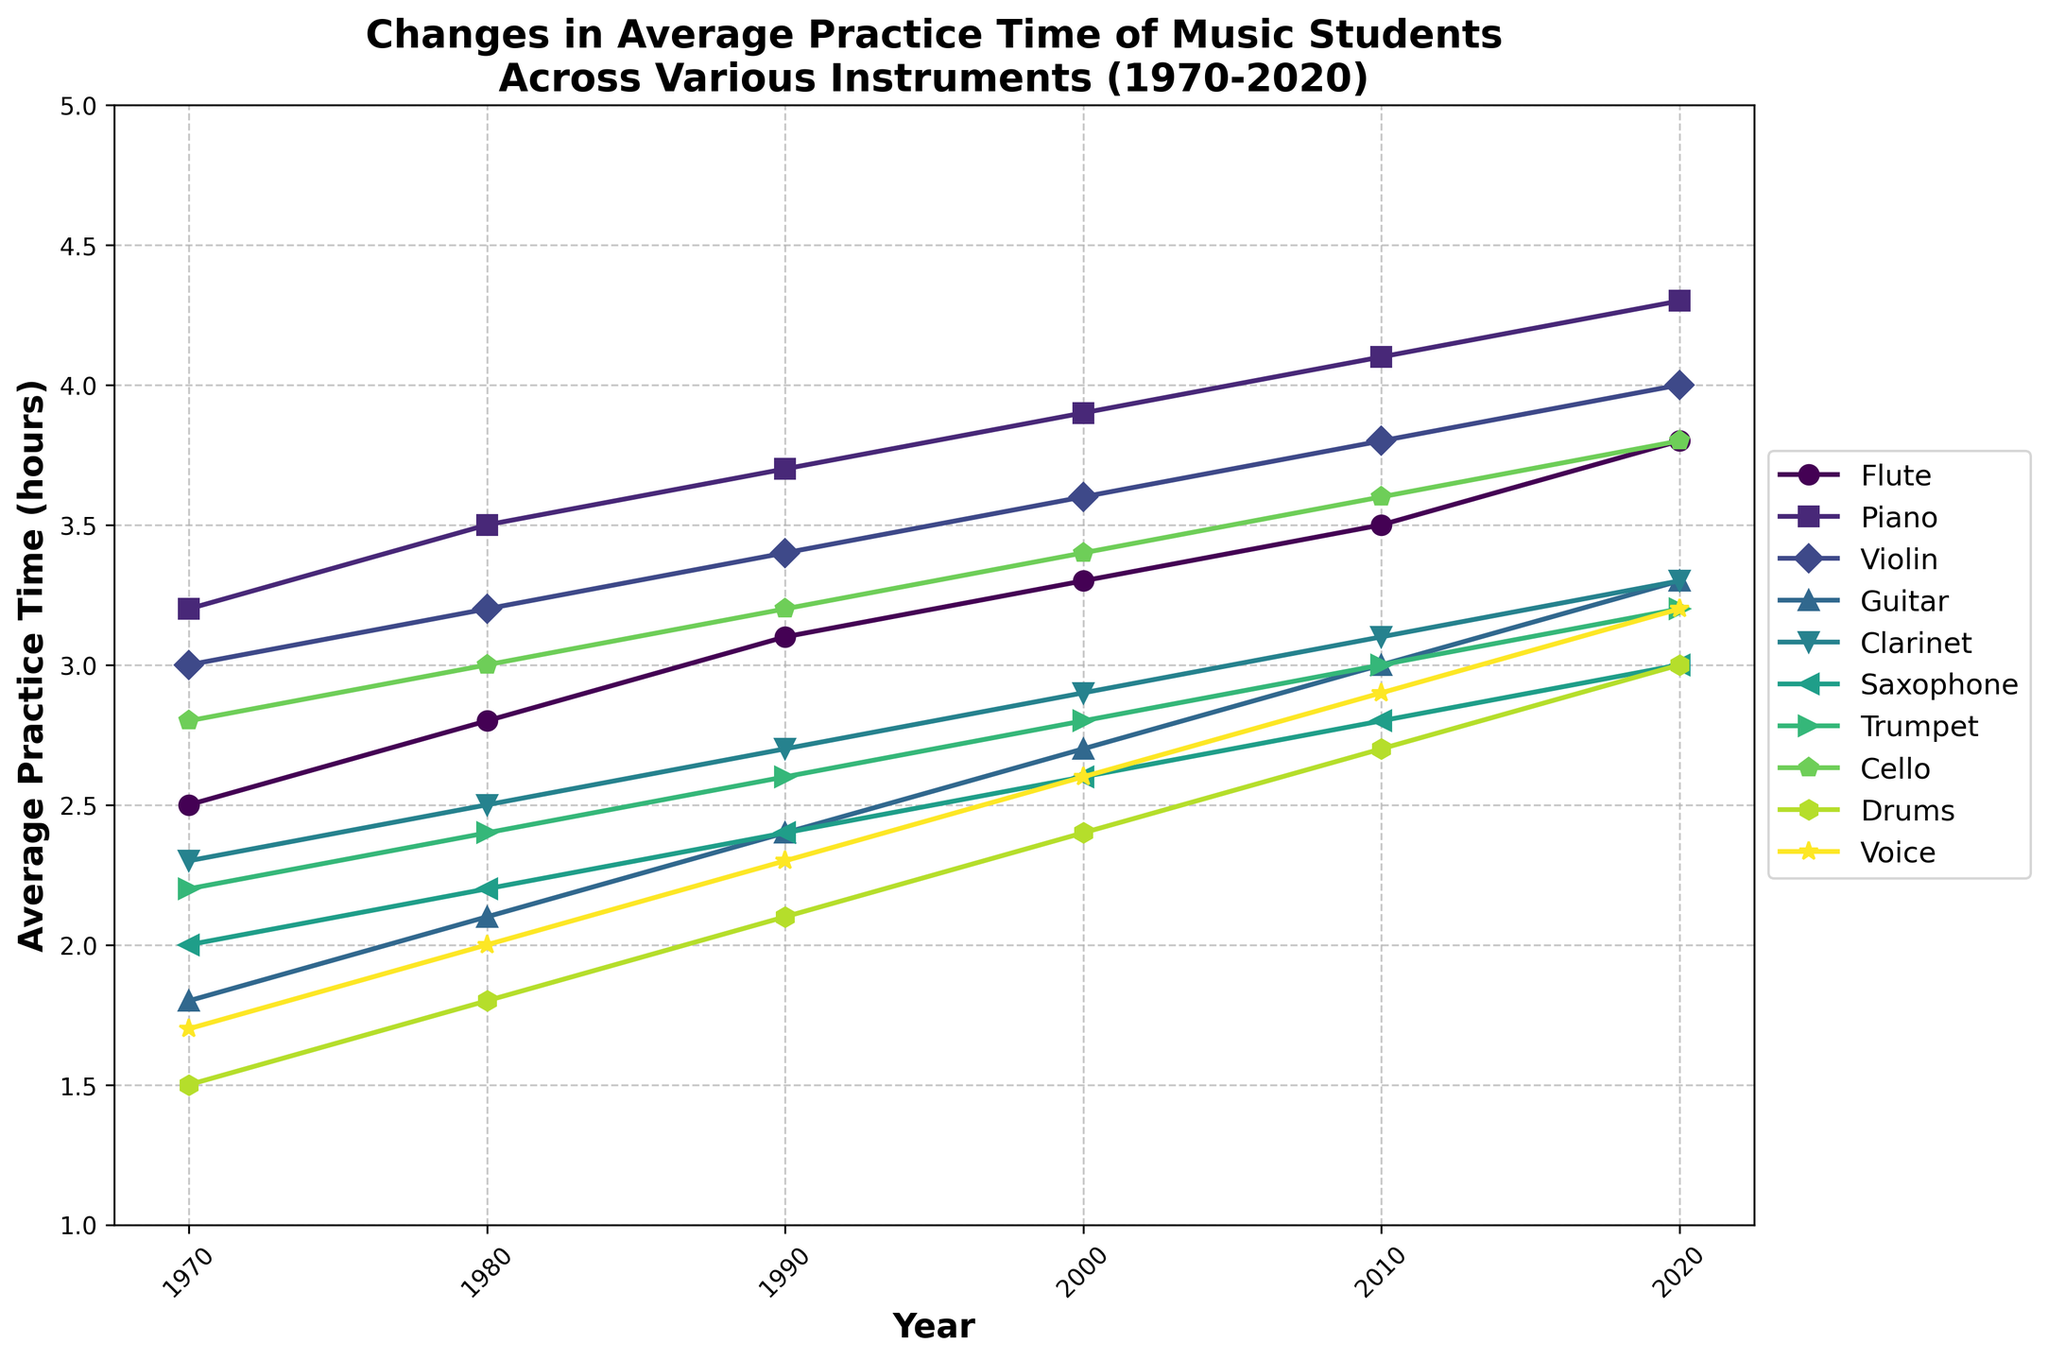What is the average practice time for the flute in 2020? The flute practice time for 2020 can be directly observed from the figure. Just look at the point corresponding to the flute in 2020.
Answer: 3.8 hours Which instrument had the highest average practice time in 2020? Compare all the values for 2020 to determine which is the highest. The piano has the highest value of 4.3 hours in 2020.
Answer: Piano Which instrument shows the greatest increase in average practice time from 1970 to 2020? Calculate the difference in practice time for each instrument between 1970 and 2020. Piano shows the largest increase from 3.2 to 4.3 hours, which is an increase of 1.1 hours.
Answer: Piano What is the average practice time for the flute from 1970 to 2020? Add the practice times for the flute between 1970 and 2020, then divide by the number of years (6). The times are 2.5, 2.8, 3.1, 3.3, 3.5, 3.8. The sum is 19 and the average is 19/6 = 3.17 hours.
Answer: 3.17 hours Which two instruments show the same practice time in any given year? Examine the practice times for each year across all instruments to find matching values. In 2020, both the saxophone and clarinet have practice times of 3.0 hours.
Answer: Saxophone, Clarinet What year did the average practice time for the drums surpass 2.0 hours? Find the year when the practice time for drums first exceeds 2.0 hours. It passed 2.0 hours in 1990 (2.1 hours).
Answer: 1990 By how much did the practice time for the guitar increase from 1980 to 2000? Calculate the difference in practice time for the guitar between 1980 and 2000. The times are 2.1 and 2.7. The increase is 2.7 - 2.1 = 0.6 hours.
Answer: 0.6 hours In which decade did the trumpet see the smallest increase in practice time? Determine the increase in practice time for each decade for the trumpet and compare. The smallest increase of 0.2 hours occurred between 1970 and 1980 (2.2 to 2.4).
Answer: 1970s Is the average practice time for the violin greater than that for the flute across all years? Calculate the average practice times for both the violin and flute across all years and compare. Violin average: (3.0+3.2+3.4+3.6+3.8+4.0)/6 = 3.5. Flute average: (2.5+2.8+3.1+3.3+3.5+3.8)/6 = 3.17. The violin average is greater.
Answer: Yes Which instrument's practice time is represented by a marker shaped like a star in the figure? Identify the instrument associated with the star-shaped marker by examining the figure's legend. The saxophone is marked with a star.
Answer: Saxophone 